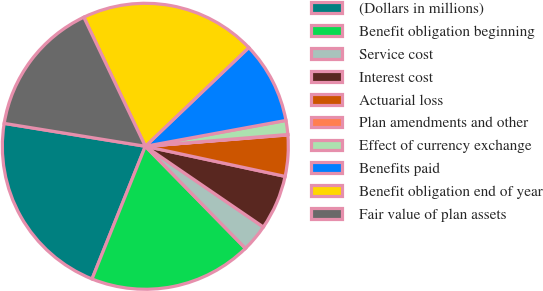Convert chart. <chart><loc_0><loc_0><loc_500><loc_500><pie_chart><fcel>(Dollars in millions)<fcel>Benefit obligation beginning<fcel>Service cost<fcel>Interest cost<fcel>Actuarial loss<fcel>Plan amendments and other<fcel>Effect of currency exchange<fcel>Benefits paid<fcel>Benefit obligation end of year<fcel>Fair value of plan assets<nl><fcel>21.48%<fcel>18.42%<fcel>3.11%<fcel>6.17%<fcel>4.64%<fcel>0.05%<fcel>1.58%<fcel>9.23%<fcel>19.95%<fcel>15.36%<nl></chart> 